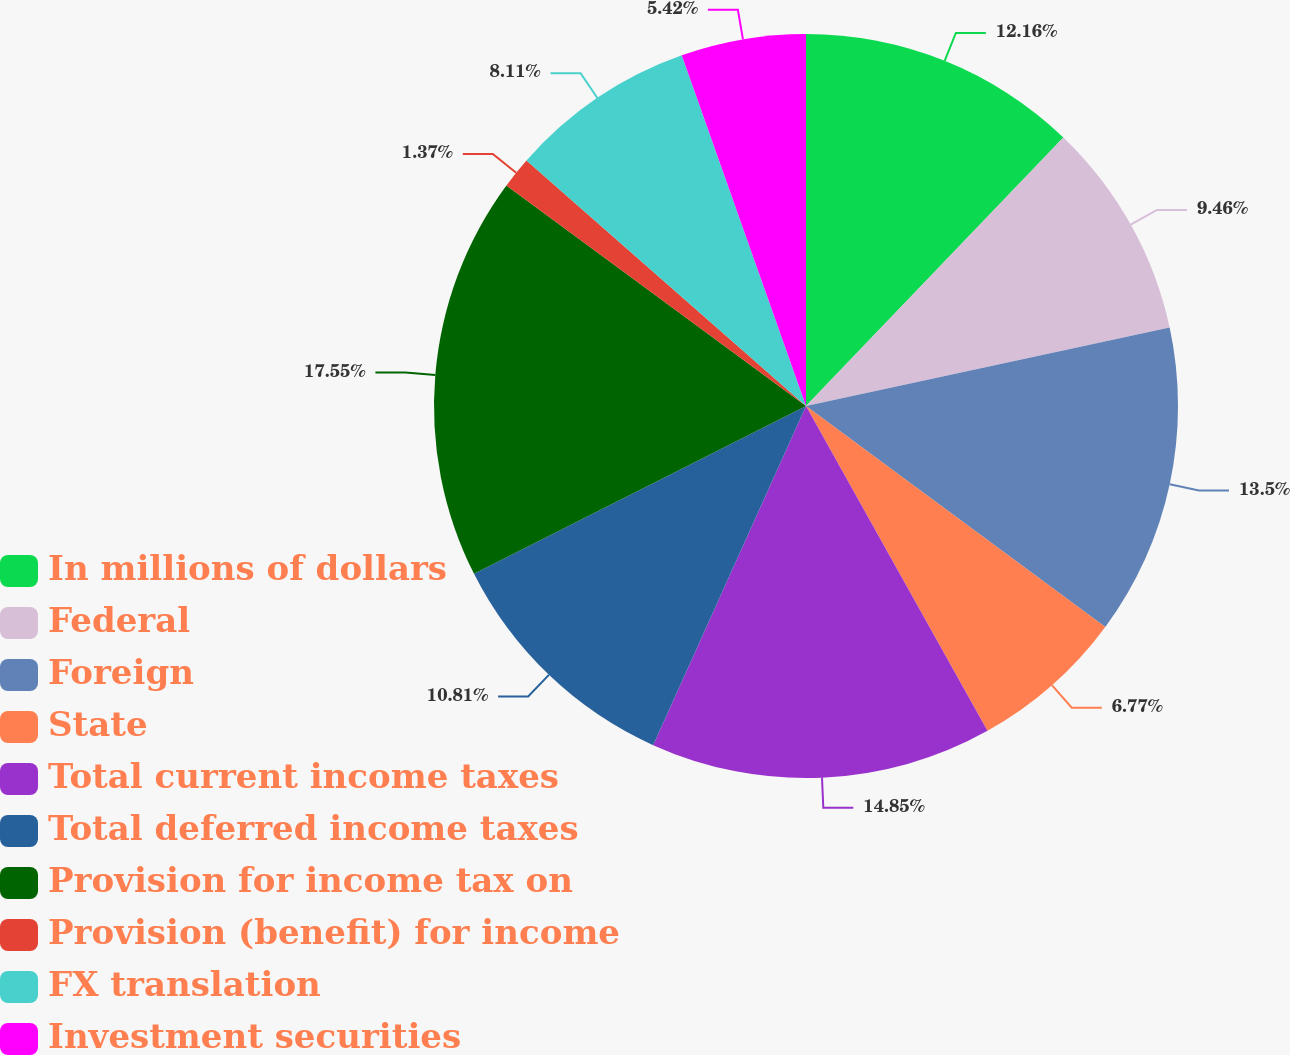Convert chart. <chart><loc_0><loc_0><loc_500><loc_500><pie_chart><fcel>In millions of dollars<fcel>Federal<fcel>Foreign<fcel>State<fcel>Total current income taxes<fcel>Total deferred income taxes<fcel>Provision for income tax on<fcel>Provision (benefit) for income<fcel>FX translation<fcel>Investment securities<nl><fcel>12.16%<fcel>9.46%<fcel>13.5%<fcel>6.77%<fcel>14.85%<fcel>10.81%<fcel>17.55%<fcel>1.37%<fcel>8.11%<fcel>5.42%<nl></chart> 